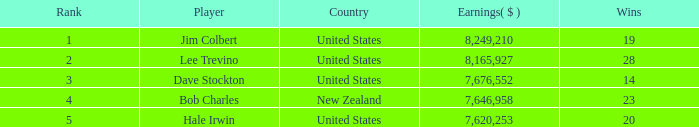How much have players earned with 14 wins ranked below 3? 0.0. 